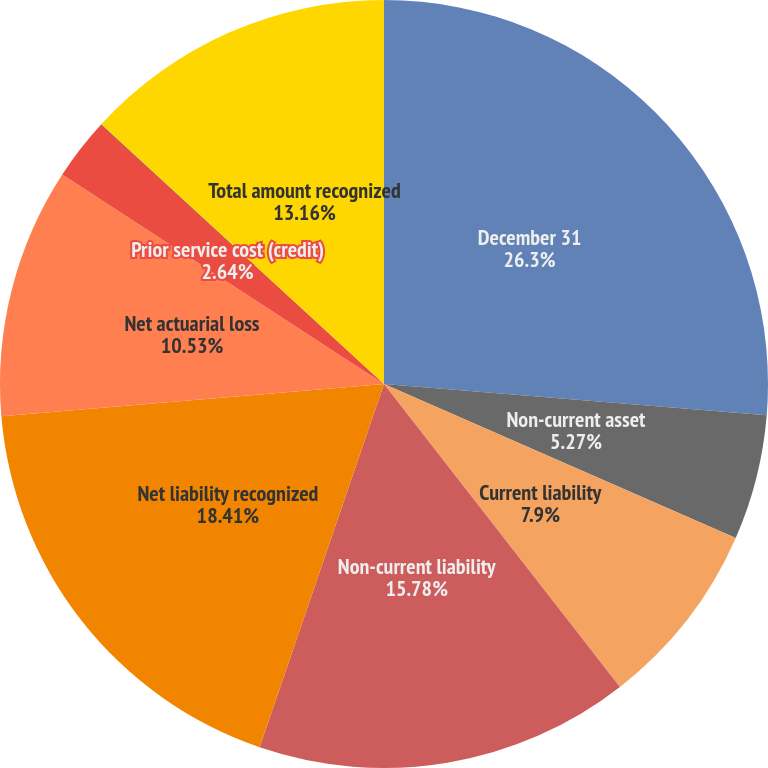<chart> <loc_0><loc_0><loc_500><loc_500><pie_chart><fcel>December 31<fcel>Non-current asset<fcel>Current liability<fcel>Non-current liability<fcel>Net liability recognized<fcel>Net actuarial loss<fcel>Prior service cost (credit)<fcel>Transition obligation<fcel>Total amount recognized<nl><fcel>26.3%<fcel>5.27%<fcel>7.9%<fcel>15.78%<fcel>18.41%<fcel>10.53%<fcel>2.64%<fcel>0.01%<fcel>13.16%<nl></chart> 